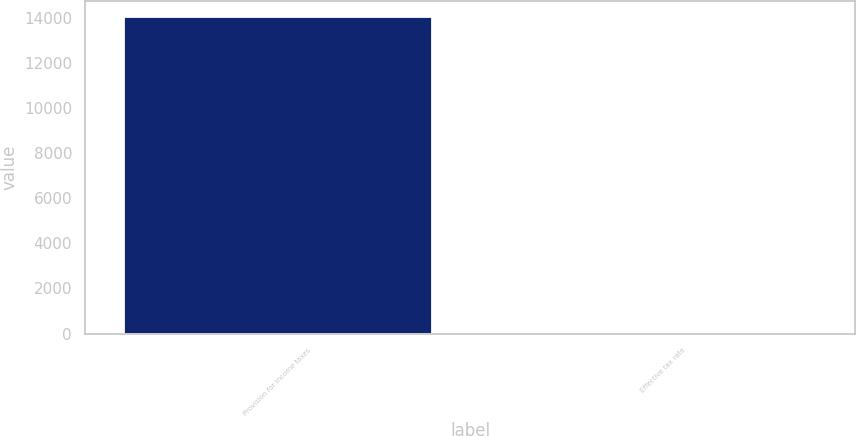Convert chart to OTSL. <chart><loc_0><loc_0><loc_500><loc_500><bar_chart><fcel>Provision for income taxes<fcel>Effective tax rate<nl><fcel>14030<fcel>25.2<nl></chart> 